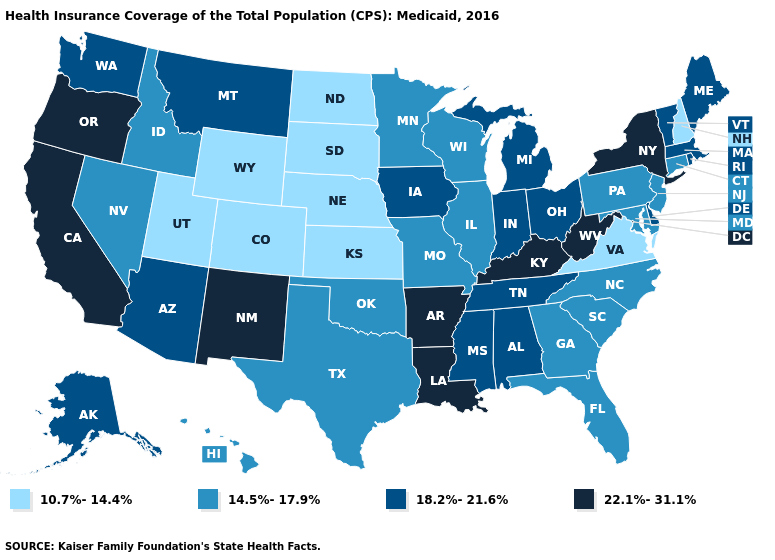Does North Carolina have the same value as Georgia?
Be succinct. Yes. What is the value of Louisiana?
Keep it brief. 22.1%-31.1%. What is the value of Oklahoma?
Answer briefly. 14.5%-17.9%. Name the states that have a value in the range 18.2%-21.6%?
Give a very brief answer. Alabama, Alaska, Arizona, Delaware, Indiana, Iowa, Maine, Massachusetts, Michigan, Mississippi, Montana, Ohio, Rhode Island, Tennessee, Vermont, Washington. What is the highest value in states that border Alabama?
Keep it brief. 18.2%-21.6%. Name the states that have a value in the range 14.5%-17.9%?
Write a very short answer. Connecticut, Florida, Georgia, Hawaii, Idaho, Illinois, Maryland, Minnesota, Missouri, Nevada, New Jersey, North Carolina, Oklahoma, Pennsylvania, South Carolina, Texas, Wisconsin. Does Utah have the lowest value in the USA?
Give a very brief answer. Yes. What is the value of Wisconsin?
Write a very short answer. 14.5%-17.9%. Name the states that have a value in the range 18.2%-21.6%?
Be succinct. Alabama, Alaska, Arizona, Delaware, Indiana, Iowa, Maine, Massachusetts, Michigan, Mississippi, Montana, Ohio, Rhode Island, Tennessee, Vermont, Washington. Among the states that border Kansas , which have the highest value?
Write a very short answer. Missouri, Oklahoma. Name the states that have a value in the range 18.2%-21.6%?
Keep it brief. Alabama, Alaska, Arizona, Delaware, Indiana, Iowa, Maine, Massachusetts, Michigan, Mississippi, Montana, Ohio, Rhode Island, Tennessee, Vermont, Washington. Is the legend a continuous bar?
Write a very short answer. No. Among the states that border Vermont , which have the lowest value?
Give a very brief answer. New Hampshire. Name the states that have a value in the range 22.1%-31.1%?
Quick response, please. Arkansas, California, Kentucky, Louisiana, New Mexico, New York, Oregon, West Virginia. Does the first symbol in the legend represent the smallest category?
Concise answer only. Yes. 